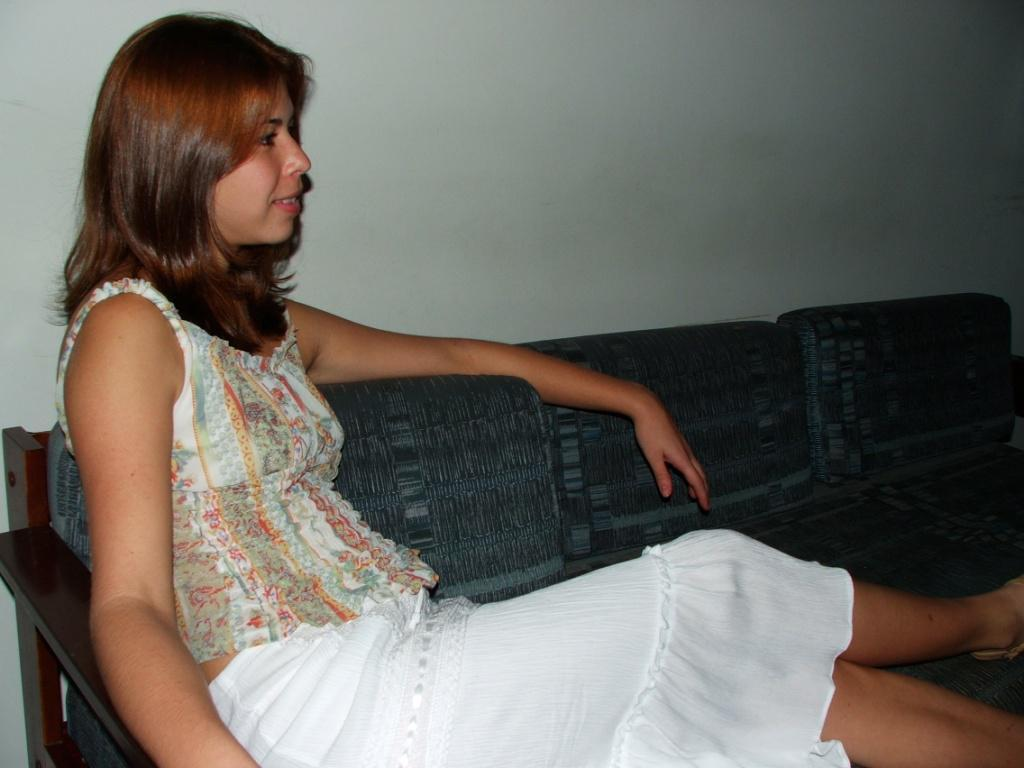Who is the main subject in the image? There is a woman in the image. What is the woman wearing? The woman is wearing a white dress. Where is the woman sitting? The woman is sitting on a grey sofa set. What color is the wall in the background of the image? There is a white wall in the background of the image. What type of payment system is being used by the woman in the image? There is no payment system present in the image; it features a woman sitting on a grey sofa set. 